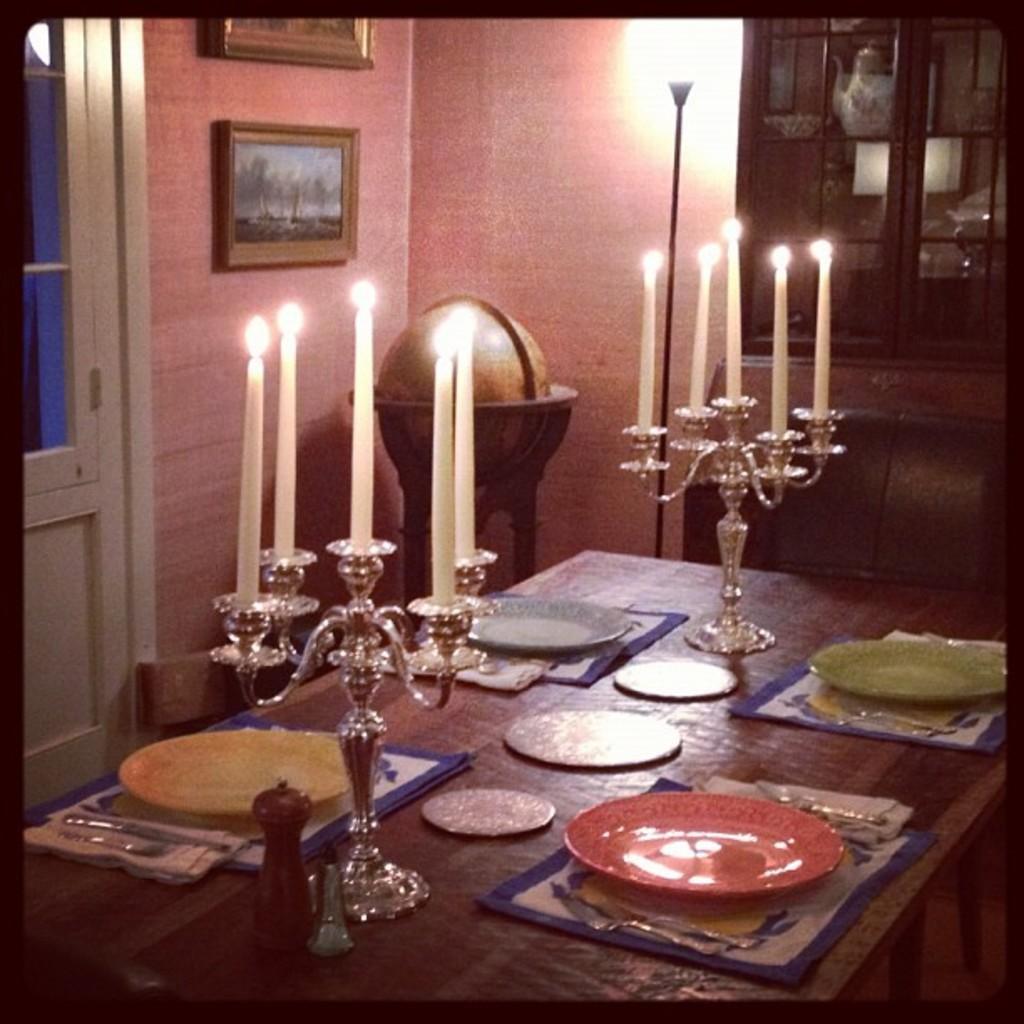Can you describe this image briefly? This picture is inside view of a room. In the center of the image there is a table. On the table we can see plates, cloth, knife, fork, candles are there. In the background of the image we can see cupboards, vessels, photo frame, door, light, wall are present. 